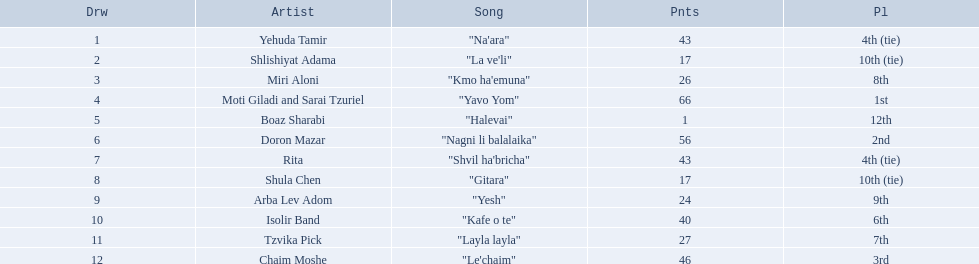What is the place of the contestant who received only 1 point? 12th. What is the name of the artist listed in the previous question? Boaz Sharabi. 